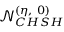<formula> <loc_0><loc_0><loc_500><loc_500>\mathcal { N } _ { C H S H } ^ { ( \eta , 0 ) }</formula> 